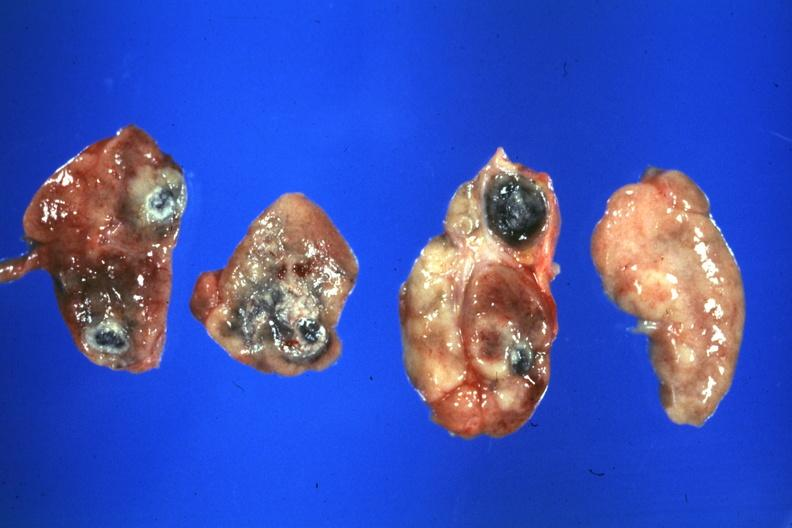s sarcoidosis present?
Answer the question using a single word or phrase. Yes 